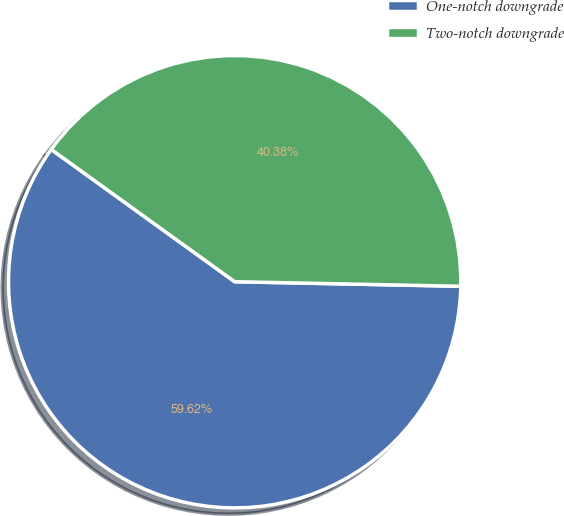<chart> <loc_0><loc_0><loc_500><loc_500><pie_chart><fcel>One-notch downgrade<fcel>Two-notch downgrade<nl><fcel>59.62%<fcel>40.38%<nl></chart> 